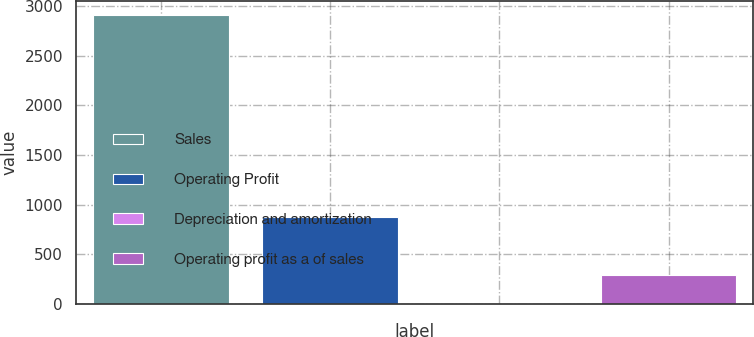<chart> <loc_0><loc_0><loc_500><loc_500><bar_chart><fcel>Sales<fcel>Operating Profit<fcel>Depreciation and amortization<fcel>Operating profit as a of sales<nl><fcel>2906.5<fcel>873.14<fcel>1.7<fcel>292.18<nl></chart> 